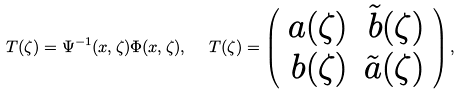<formula> <loc_0><loc_0><loc_500><loc_500>T ( \zeta ) = \Psi ^ { - 1 } ( x , \zeta ) \Phi ( x , \zeta ) , \ \ T ( \zeta ) = \left ( \begin{array} { r r } a ( \zeta ) & \tilde { b } ( \zeta ) \\ b ( \zeta ) & \tilde { a } ( \zeta ) \end{array} \right ) ,</formula> 